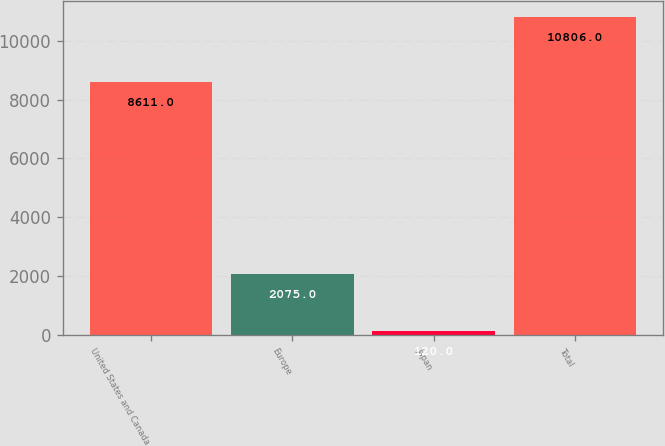Convert chart. <chart><loc_0><loc_0><loc_500><loc_500><bar_chart><fcel>United States and Canada<fcel>Europe<fcel>Japan<fcel>Total<nl><fcel>8611<fcel>2075<fcel>120<fcel>10806<nl></chart> 